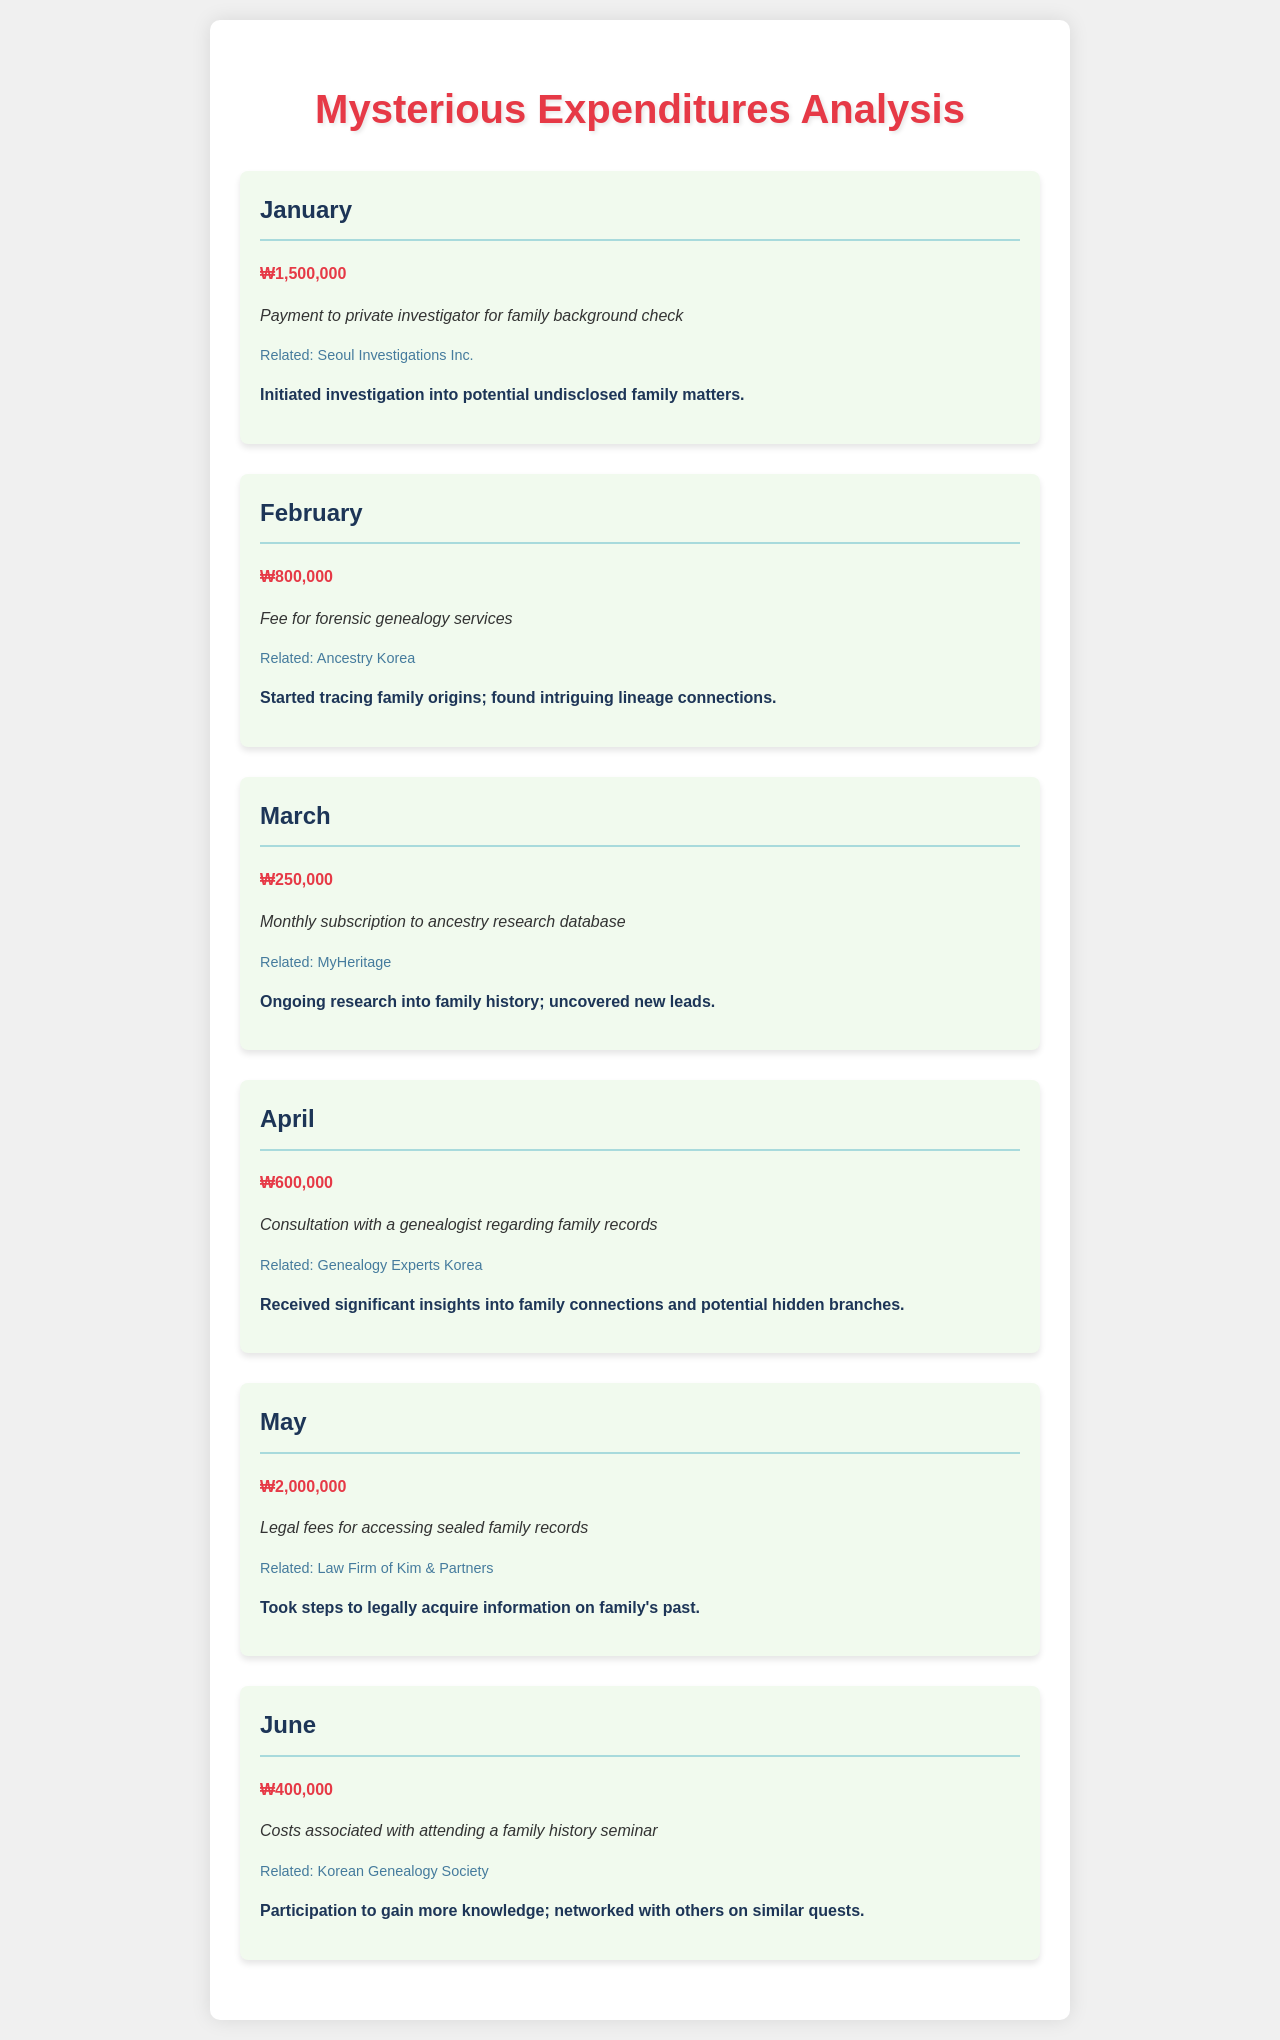what was the expenditure in January? The expenditure in January is listed as ₩1,500,000 for a payment to a private investigator.
Answer: ₩1,500,000 what did the January expenditure indicate? The January expenditure indicates an investigation into potential undisclosed family matters.
Answer: undisclosed family matters who did the consultation in April? The consultation in April was with Genealogy Experts Korea regarding family records.
Answer: Genealogy Experts Korea how much was spent in February on genealogy services? The expenditure in February was ₩800,000 for forensic genealogy services.
Answer: ₩800,000 what type of service was purchased in May? In May, legal fees were paid for accessing sealed family records.
Answer: legal fees which month had the highest expenditure? The month with the highest expenditure was May with ₩2,000,000.
Answer: May what was the focus of the expenditures throughout the months? The focus of the expenditures was on uncovering and exploring family history and connections.
Answer: family history what type of seminar was attended in June? The seminar attended in June was related to family history, organized by the Korean Genealogy Society.
Answer: family history seminar what was the amount of expenditure for the monthly subscription in March? The expenditure for the monthly subscription in March was ₩250,000.
Answer: ₩250,000 